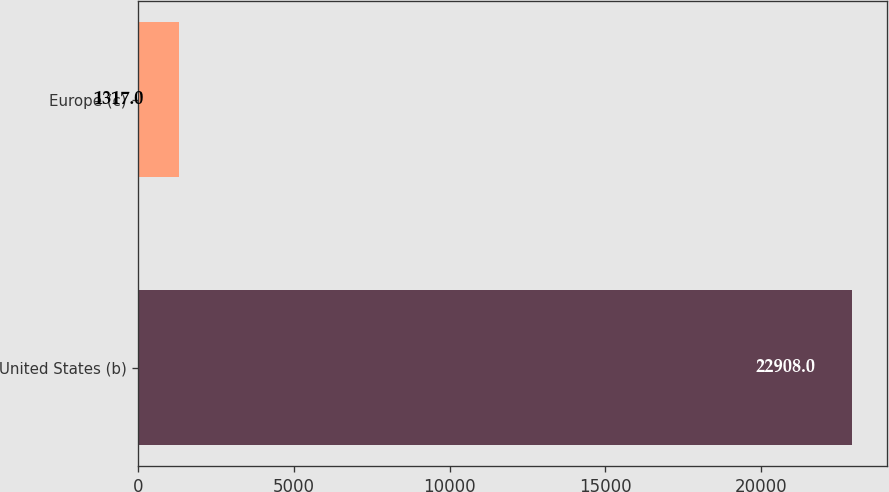Convert chart to OTSL. <chart><loc_0><loc_0><loc_500><loc_500><bar_chart><fcel>United States (b)<fcel>Europe (c)<nl><fcel>22908<fcel>1317<nl></chart> 